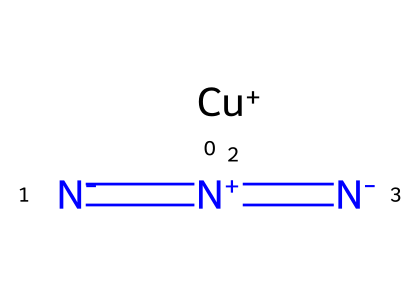How many nitrogen atoms are present in copper(I) azide? The SMILES representation shows three nitrogen atoms connected in a linear configuration, indicating the presence of three N atoms.
Answer: three What is the central metal atom in copper(I) azide? The SMILES specifies "[Cu+]" indicating that copper is the central metal atom present in this compound.
Answer: copper How many total bonds are indicated in the structure of copper(I) azide? Analyzing the SMILES, the nitrogen atoms are connected by double bonds (2) among themselves and one bond connects to the copper, giving a total of three bonds.
Answer: three What is the oxidation state of copper in copper(I) azide? The notation "[Cu+]" indicates that the copper in this azide compound has a +1 oxidation state.
Answer: +1 What type of reaction can copper(I) azide be used in? Copper(I) azide is commonly used in click chemistry reactions, which facilitate the formation of chemical bonds swiftly and efficiently.
Answer: click chemistry What type of chemical is copper(I) azide categorized as? Given the presence of the azide group, copper(I) azide is categorized specifically as an azide compound, characterized by nitrogen-nitrogen bonds.
Answer: azide 